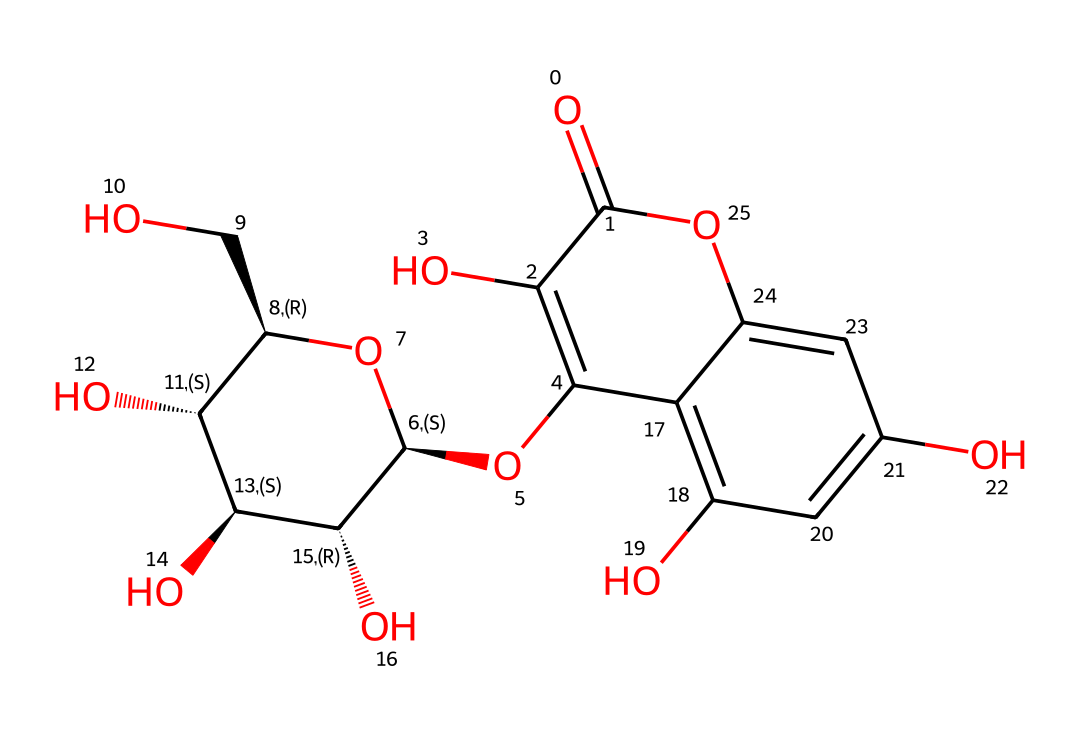What is the main functional group present in this chemical? The molecule contains multiple hydroxyl groups (-OH) as indicated by the presence of several oxygen atoms bonded to carbon. These contribute to its properties as a natural dye.
Answer: hydroxyl group How many carbon atoms are in this molecule? By counting the carbon atoms present in the SMILES representation, we identify 15 carbon atoms. Each carbon is typically indicated in the resulting structure.
Answer: 15 What type of compound is this chemical classified as? The presence of multiple hydroxyl groups and the overall structure indicates that it is a phenolic compound, which is characteristic of many natural dyes.
Answer: phenolic Does this chemical have any double bonds? Analyzing the structure reveals multiple carbon-carbon double bonds (C=C) present in the molecule's framework, confirming the presence of unsaturation.
Answer: yes What is the net charge of this molecule? Since the SMILES representation does not indicate any charged groups (like ammonium or carboxylate), we can conclude that the molecule has a neutral charge overall.
Answer: neutral Which part of this chemical structure is responsible for its color? The conjugated double bonds in the cyclic rings facilitate light absorption at specific wavelengths, contributing to the color properties typical of many natural dyes.
Answer: conjugated double bonds How many hydroxyl groups are present in this structure? By examining the molecule and counting the -OH groups, we find that there are six hydroxyl groups attached, which aids in solubility and reactivity.
Answer: six 